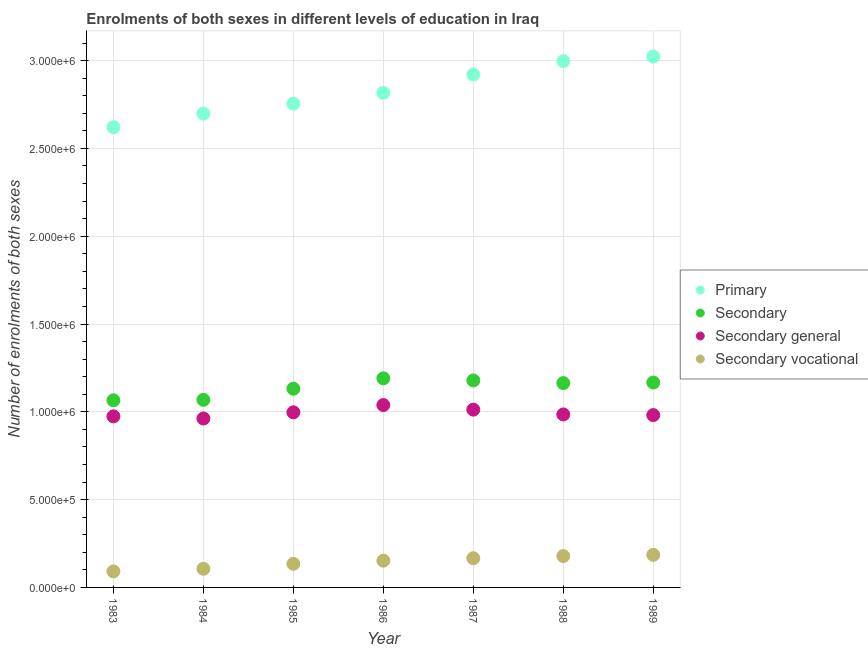What is the number of enrolments in primary education in 1983?
Your answer should be very brief. 2.62e+06. Across all years, what is the maximum number of enrolments in primary education?
Offer a terse response. 3.02e+06. Across all years, what is the minimum number of enrolments in secondary education?
Your answer should be compact. 1.07e+06. In which year was the number of enrolments in primary education maximum?
Give a very brief answer. 1989. What is the total number of enrolments in secondary vocational education in the graph?
Your answer should be compact. 1.01e+06. What is the difference between the number of enrolments in secondary education in 1983 and that in 1989?
Give a very brief answer. -1.01e+05. What is the difference between the number of enrolments in secondary education in 1989 and the number of enrolments in primary education in 1985?
Your answer should be very brief. -1.59e+06. What is the average number of enrolments in secondary general education per year?
Offer a terse response. 9.93e+05. In the year 1984, what is the difference between the number of enrolments in primary education and number of enrolments in secondary vocational education?
Provide a short and direct response. 2.59e+06. In how many years, is the number of enrolments in secondary general education greater than 1100000?
Your response must be concise. 0. What is the ratio of the number of enrolments in secondary general education in 1984 to that in 1989?
Keep it short and to the point. 0.98. Is the number of enrolments in primary education in 1983 less than that in 1989?
Offer a terse response. Yes. Is the difference between the number of enrolments in secondary general education in 1984 and 1988 greater than the difference between the number of enrolments in secondary education in 1984 and 1988?
Provide a succinct answer. Yes. What is the difference between the highest and the second highest number of enrolments in secondary general education?
Offer a very short reply. 2.62e+04. What is the difference between the highest and the lowest number of enrolments in primary education?
Provide a succinct answer. 4.02e+05. In how many years, is the number of enrolments in primary education greater than the average number of enrolments in primary education taken over all years?
Make the answer very short. 3. Is the sum of the number of enrolments in secondary general education in 1983 and 1986 greater than the maximum number of enrolments in secondary vocational education across all years?
Your answer should be compact. Yes. Is it the case that in every year, the sum of the number of enrolments in secondary education and number of enrolments in secondary vocational education is greater than the sum of number of enrolments in primary education and number of enrolments in secondary general education?
Keep it short and to the point. No. Does the number of enrolments in secondary vocational education monotonically increase over the years?
Keep it short and to the point. Yes. Is the number of enrolments in secondary vocational education strictly greater than the number of enrolments in primary education over the years?
Make the answer very short. No. How many dotlines are there?
Offer a very short reply. 4. What is the difference between two consecutive major ticks on the Y-axis?
Keep it short and to the point. 5.00e+05. Does the graph contain grids?
Your response must be concise. Yes. Where does the legend appear in the graph?
Your answer should be compact. Center right. How many legend labels are there?
Your response must be concise. 4. How are the legend labels stacked?
Provide a succinct answer. Vertical. What is the title of the graph?
Provide a succinct answer. Enrolments of both sexes in different levels of education in Iraq. What is the label or title of the X-axis?
Offer a very short reply. Year. What is the label or title of the Y-axis?
Your answer should be compact. Number of enrolments of both sexes. What is the Number of enrolments of both sexes in Primary in 1983?
Provide a succinct answer. 2.62e+06. What is the Number of enrolments of both sexes in Secondary in 1983?
Ensure brevity in your answer.  1.07e+06. What is the Number of enrolments of both sexes in Secondary general in 1983?
Your answer should be very brief. 9.74e+05. What is the Number of enrolments of both sexes in Secondary vocational in 1983?
Your answer should be very brief. 9.13e+04. What is the Number of enrolments of both sexes of Primary in 1984?
Ensure brevity in your answer.  2.70e+06. What is the Number of enrolments of both sexes in Secondary in 1984?
Give a very brief answer. 1.07e+06. What is the Number of enrolments of both sexes of Secondary general in 1984?
Make the answer very short. 9.62e+05. What is the Number of enrolments of both sexes in Secondary vocational in 1984?
Keep it short and to the point. 1.06e+05. What is the Number of enrolments of both sexes of Primary in 1985?
Keep it short and to the point. 2.75e+06. What is the Number of enrolments of both sexes in Secondary in 1985?
Make the answer very short. 1.13e+06. What is the Number of enrolments of both sexes of Secondary general in 1985?
Ensure brevity in your answer.  9.97e+05. What is the Number of enrolments of both sexes in Secondary vocational in 1985?
Your response must be concise. 1.34e+05. What is the Number of enrolments of both sexes in Primary in 1986?
Your answer should be very brief. 2.82e+06. What is the Number of enrolments of both sexes of Secondary in 1986?
Ensure brevity in your answer.  1.19e+06. What is the Number of enrolments of both sexes of Secondary general in 1986?
Provide a short and direct response. 1.04e+06. What is the Number of enrolments of both sexes in Secondary vocational in 1986?
Your response must be concise. 1.52e+05. What is the Number of enrolments of both sexes of Primary in 1987?
Keep it short and to the point. 2.92e+06. What is the Number of enrolments of both sexes in Secondary in 1987?
Ensure brevity in your answer.  1.18e+06. What is the Number of enrolments of both sexes in Secondary general in 1987?
Make the answer very short. 1.01e+06. What is the Number of enrolments of both sexes of Secondary vocational in 1987?
Your answer should be very brief. 1.66e+05. What is the Number of enrolments of both sexes of Primary in 1988?
Give a very brief answer. 3.00e+06. What is the Number of enrolments of both sexes in Secondary in 1988?
Your answer should be compact. 1.16e+06. What is the Number of enrolments of both sexes in Secondary general in 1988?
Offer a terse response. 9.85e+05. What is the Number of enrolments of both sexes of Secondary vocational in 1988?
Provide a succinct answer. 1.79e+05. What is the Number of enrolments of both sexes of Primary in 1989?
Offer a terse response. 3.02e+06. What is the Number of enrolments of both sexes of Secondary in 1989?
Provide a short and direct response. 1.17e+06. What is the Number of enrolments of both sexes of Secondary general in 1989?
Provide a short and direct response. 9.81e+05. What is the Number of enrolments of both sexes of Secondary vocational in 1989?
Your answer should be compact. 1.85e+05. Across all years, what is the maximum Number of enrolments of both sexes in Primary?
Offer a very short reply. 3.02e+06. Across all years, what is the maximum Number of enrolments of both sexes in Secondary?
Provide a short and direct response. 1.19e+06. Across all years, what is the maximum Number of enrolments of both sexes in Secondary general?
Provide a short and direct response. 1.04e+06. Across all years, what is the maximum Number of enrolments of both sexes in Secondary vocational?
Your answer should be compact. 1.85e+05. Across all years, what is the minimum Number of enrolments of both sexes of Primary?
Provide a succinct answer. 2.62e+06. Across all years, what is the minimum Number of enrolments of both sexes in Secondary?
Make the answer very short. 1.07e+06. Across all years, what is the minimum Number of enrolments of both sexes in Secondary general?
Ensure brevity in your answer.  9.62e+05. Across all years, what is the minimum Number of enrolments of both sexes of Secondary vocational?
Offer a very short reply. 9.13e+04. What is the total Number of enrolments of both sexes in Primary in the graph?
Offer a terse response. 1.98e+07. What is the total Number of enrolments of both sexes in Secondary in the graph?
Keep it short and to the point. 7.97e+06. What is the total Number of enrolments of both sexes in Secondary general in the graph?
Offer a terse response. 6.95e+06. What is the total Number of enrolments of both sexes in Secondary vocational in the graph?
Your answer should be compact. 1.01e+06. What is the difference between the Number of enrolments of both sexes in Primary in 1983 and that in 1984?
Ensure brevity in your answer.  -7.77e+04. What is the difference between the Number of enrolments of both sexes in Secondary in 1983 and that in 1984?
Offer a very short reply. -2636. What is the difference between the Number of enrolments of both sexes in Secondary general in 1983 and that in 1984?
Provide a short and direct response. 1.22e+04. What is the difference between the Number of enrolments of both sexes of Secondary vocational in 1983 and that in 1984?
Your response must be concise. -1.49e+04. What is the difference between the Number of enrolments of both sexes in Primary in 1983 and that in 1985?
Ensure brevity in your answer.  -1.34e+05. What is the difference between the Number of enrolments of both sexes of Secondary in 1983 and that in 1985?
Provide a succinct answer. -6.59e+04. What is the difference between the Number of enrolments of both sexes in Secondary general in 1983 and that in 1985?
Give a very brief answer. -2.28e+04. What is the difference between the Number of enrolments of both sexes of Secondary vocational in 1983 and that in 1985?
Provide a short and direct response. -4.31e+04. What is the difference between the Number of enrolments of both sexes of Primary in 1983 and that in 1986?
Your answer should be very brief. -1.95e+05. What is the difference between the Number of enrolments of both sexes of Secondary in 1983 and that in 1986?
Keep it short and to the point. -1.25e+05. What is the difference between the Number of enrolments of both sexes of Secondary general in 1983 and that in 1986?
Provide a short and direct response. -6.44e+04. What is the difference between the Number of enrolments of both sexes in Secondary vocational in 1983 and that in 1986?
Ensure brevity in your answer.  -6.09e+04. What is the difference between the Number of enrolments of both sexes of Primary in 1983 and that in 1987?
Ensure brevity in your answer.  -3.00e+05. What is the difference between the Number of enrolments of both sexes in Secondary in 1983 and that in 1987?
Your answer should be compact. -1.13e+05. What is the difference between the Number of enrolments of both sexes in Secondary general in 1983 and that in 1987?
Your answer should be compact. -3.82e+04. What is the difference between the Number of enrolments of both sexes of Secondary vocational in 1983 and that in 1987?
Your answer should be compact. -7.50e+04. What is the difference between the Number of enrolments of both sexes of Primary in 1983 and that in 1988?
Your response must be concise. -3.76e+05. What is the difference between the Number of enrolments of both sexes in Secondary in 1983 and that in 1988?
Your answer should be compact. -9.81e+04. What is the difference between the Number of enrolments of both sexes in Secondary general in 1983 and that in 1988?
Make the answer very short. -1.09e+04. What is the difference between the Number of enrolments of both sexes in Secondary vocational in 1983 and that in 1988?
Your answer should be compact. -8.72e+04. What is the difference between the Number of enrolments of both sexes in Primary in 1983 and that in 1989?
Your answer should be very brief. -4.02e+05. What is the difference between the Number of enrolments of both sexes in Secondary in 1983 and that in 1989?
Your response must be concise. -1.01e+05. What is the difference between the Number of enrolments of both sexes of Secondary general in 1983 and that in 1989?
Offer a very short reply. -7159. What is the difference between the Number of enrolments of both sexes in Secondary vocational in 1983 and that in 1989?
Provide a short and direct response. -9.41e+04. What is the difference between the Number of enrolments of both sexes in Primary in 1984 and that in 1985?
Offer a terse response. -5.63e+04. What is the difference between the Number of enrolments of both sexes in Secondary in 1984 and that in 1985?
Keep it short and to the point. -6.33e+04. What is the difference between the Number of enrolments of both sexes of Secondary general in 1984 and that in 1985?
Make the answer very short. -3.51e+04. What is the difference between the Number of enrolments of both sexes of Secondary vocational in 1984 and that in 1985?
Your answer should be compact. -2.82e+04. What is the difference between the Number of enrolments of both sexes of Primary in 1984 and that in 1986?
Keep it short and to the point. -1.18e+05. What is the difference between the Number of enrolments of both sexes of Secondary in 1984 and that in 1986?
Your answer should be very brief. -1.23e+05. What is the difference between the Number of enrolments of both sexes of Secondary general in 1984 and that in 1986?
Provide a succinct answer. -7.66e+04. What is the difference between the Number of enrolments of both sexes in Secondary vocational in 1984 and that in 1986?
Your answer should be very brief. -4.60e+04. What is the difference between the Number of enrolments of both sexes of Primary in 1984 and that in 1987?
Keep it short and to the point. -2.22e+05. What is the difference between the Number of enrolments of both sexes in Secondary in 1984 and that in 1987?
Give a very brief answer. -1.11e+05. What is the difference between the Number of enrolments of both sexes in Secondary general in 1984 and that in 1987?
Your answer should be very brief. -5.04e+04. What is the difference between the Number of enrolments of both sexes of Secondary vocational in 1984 and that in 1987?
Make the answer very short. -6.01e+04. What is the difference between the Number of enrolments of both sexes in Primary in 1984 and that in 1988?
Keep it short and to the point. -2.98e+05. What is the difference between the Number of enrolments of both sexes in Secondary in 1984 and that in 1988?
Offer a very short reply. -9.55e+04. What is the difference between the Number of enrolments of both sexes in Secondary general in 1984 and that in 1988?
Your answer should be compact. -2.31e+04. What is the difference between the Number of enrolments of both sexes of Secondary vocational in 1984 and that in 1988?
Give a very brief answer. -7.24e+04. What is the difference between the Number of enrolments of both sexes of Primary in 1984 and that in 1989?
Keep it short and to the point. -3.25e+05. What is the difference between the Number of enrolments of both sexes in Secondary in 1984 and that in 1989?
Offer a terse response. -9.86e+04. What is the difference between the Number of enrolments of both sexes in Secondary general in 1984 and that in 1989?
Provide a short and direct response. -1.94e+04. What is the difference between the Number of enrolments of both sexes of Secondary vocational in 1984 and that in 1989?
Provide a succinct answer. -7.92e+04. What is the difference between the Number of enrolments of both sexes of Primary in 1985 and that in 1986?
Your answer should be very brief. -6.14e+04. What is the difference between the Number of enrolments of both sexes in Secondary in 1985 and that in 1986?
Your answer should be very brief. -5.93e+04. What is the difference between the Number of enrolments of both sexes in Secondary general in 1985 and that in 1986?
Keep it short and to the point. -4.16e+04. What is the difference between the Number of enrolments of both sexes of Secondary vocational in 1985 and that in 1986?
Give a very brief answer. -1.78e+04. What is the difference between the Number of enrolments of both sexes of Primary in 1985 and that in 1987?
Offer a very short reply. -1.66e+05. What is the difference between the Number of enrolments of both sexes of Secondary in 1985 and that in 1987?
Your response must be concise. -4.72e+04. What is the difference between the Number of enrolments of both sexes in Secondary general in 1985 and that in 1987?
Offer a very short reply. -1.54e+04. What is the difference between the Number of enrolments of both sexes of Secondary vocational in 1985 and that in 1987?
Provide a succinct answer. -3.19e+04. What is the difference between the Number of enrolments of both sexes of Primary in 1985 and that in 1988?
Your response must be concise. -2.42e+05. What is the difference between the Number of enrolments of both sexes of Secondary in 1985 and that in 1988?
Make the answer very short. -3.22e+04. What is the difference between the Number of enrolments of both sexes in Secondary general in 1985 and that in 1988?
Provide a succinct answer. 1.19e+04. What is the difference between the Number of enrolments of both sexes of Secondary vocational in 1985 and that in 1988?
Ensure brevity in your answer.  -4.41e+04. What is the difference between the Number of enrolments of both sexes in Primary in 1985 and that in 1989?
Provide a succinct answer. -2.68e+05. What is the difference between the Number of enrolments of both sexes in Secondary in 1985 and that in 1989?
Your response must be concise. -3.53e+04. What is the difference between the Number of enrolments of both sexes in Secondary general in 1985 and that in 1989?
Your answer should be very brief. 1.57e+04. What is the difference between the Number of enrolments of both sexes of Secondary vocational in 1985 and that in 1989?
Your answer should be very brief. -5.10e+04. What is the difference between the Number of enrolments of both sexes in Primary in 1986 and that in 1987?
Give a very brief answer. -1.05e+05. What is the difference between the Number of enrolments of both sexes of Secondary in 1986 and that in 1987?
Keep it short and to the point. 1.21e+04. What is the difference between the Number of enrolments of both sexes of Secondary general in 1986 and that in 1987?
Offer a terse response. 2.62e+04. What is the difference between the Number of enrolments of both sexes of Secondary vocational in 1986 and that in 1987?
Give a very brief answer. -1.41e+04. What is the difference between the Number of enrolments of both sexes in Primary in 1986 and that in 1988?
Keep it short and to the point. -1.81e+05. What is the difference between the Number of enrolments of both sexes in Secondary in 1986 and that in 1988?
Your answer should be compact. 2.71e+04. What is the difference between the Number of enrolments of both sexes in Secondary general in 1986 and that in 1988?
Your answer should be compact. 5.35e+04. What is the difference between the Number of enrolments of both sexes of Secondary vocational in 1986 and that in 1988?
Give a very brief answer. -2.64e+04. What is the difference between the Number of enrolments of both sexes in Primary in 1986 and that in 1989?
Ensure brevity in your answer.  -2.07e+05. What is the difference between the Number of enrolments of both sexes in Secondary in 1986 and that in 1989?
Ensure brevity in your answer.  2.40e+04. What is the difference between the Number of enrolments of both sexes of Secondary general in 1986 and that in 1989?
Offer a very short reply. 5.72e+04. What is the difference between the Number of enrolments of both sexes of Secondary vocational in 1986 and that in 1989?
Your answer should be compact. -3.32e+04. What is the difference between the Number of enrolments of both sexes in Primary in 1987 and that in 1988?
Provide a short and direct response. -7.60e+04. What is the difference between the Number of enrolments of both sexes in Secondary in 1987 and that in 1988?
Offer a very short reply. 1.51e+04. What is the difference between the Number of enrolments of both sexes in Secondary general in 1987 and that in 1988?
Make the answer very short. 2.73e+04. What is the difference between the Number of enrolments of both sexes of Secondary vocational in 1987 and that in 1988?
Offer a terse response. -1.22e+04. What is the difference between the Number of enrolments of both sexes in Primary in 1987 and that in 1989?
Your answer should be very brief. -1.02e+05. What is the difference between the Number of enrolments of both sexes in Secondary in 1987 and that in 1989?
Ensure brevity in your answer.  1.19e+04. What is the difference between the Number of enrolments of both sexes in Secondary general in 1987 and that in 1989?
Provide a succinct answer. 3.10e+04. What is the difference between the Number of enrolments of both sexes of Secondary vocational in 1987 and that in 1989?
Your response must be concise. -1.91e+04. What is the difference between the Number of enrolments of both sexes of Primary in 1988 and that in 1989?
Keep it short and to the point. -2.62e+04. What is the difference between the Number of enrolments of both sexes of Secondary in 1988 and that in 1989?
Keep it short and to the point. -3165. What is the difference between the Number of enrolments of both sexes in Secondary general in 1988 and that in 1989?
Your response must be concise. 3714. What is the difference between the Number of enrolments of both sexes in Secondary vocational in 1988 and that in 1989?
Your answer should be very brief. -6879. What is the difference between the Number of enrolments of both sexes in Primary in 1983 and the Number of enrolments of both sexes in Secondary in 1984?
Make the answer very short. 1.55e+06. What is the difference between the Number of enrolments of both sexes of Primary in 1983 and the Number of enrolments of both sexes of Secondary general in 1984?
Keep it short and to the point. 1.66e+06. What is the difference between the Number of enrolments of both sexes in Primary in 1983 and the Number of enrolments of both sexes in Secondary vocational in 1984?
Provide a short and direct response. 2.51e+06. What is the difference between the Number of enrolments of both sexes in Secondary in 1983 and the Number of enrolments of both sexes in Secondary general in 1984?
Ensure brevity in your answer.  1.04e+05. What is the difference between the Number of enrolments of both sexes of Secondary in 1983 and the Number of enrolments of both sexes of Secondary vocational in 1984?
Your answer should be compact. 9.59e+05. What is the difference between the Number of enrolments of both sexes of Secondary general in 1983 and the Number of enrolments of both sexes of Secondary vocational in 1984?
Make the answer very short. 8.68e+05. What is the difference between the Number of enrolments of both sexes in Primary in 1983 and the Number of enrolments of both sexes in Secondary in 1985?
Provide a short and direct response. 1.49e+06. What is the difference between the Number of enrolments of both sexes in Primary in 1983 and the Number of enrolments of both sexes in Secondary general in 1985?
Your answer should be very brief. 1.62e+06. What is the difference between the Number of enrolments of both sexes of Primary in 1983 and the Number of enrolments of both sexes of Secondary vocational in 1985?
Your response must be concise. 2.49e+06. What is the difference between the Number of enrolments of both sexes in Secondary in 1983 and the Number of enrolments of both sexes in Secondary general in 1985?
Your answer should be compact. 6.85e+04. What is the difference between the Number of enrolments of both sexes of Secondary in 1983 and the Number of enrolments of both sexes of Secondary vocational in 1985?
Provide a succinct answer. 9.31e+05. What is the difference between the Number of enrolments of both sexes of Secondary general in 1983 and the Number of enrolments of both sexes of Secondary vocational in 1985?
Provide a short and direct response. 8.40e+05. What is the difference between the Number of enrolments of both sexes of Primary in 1983 and the Number of enrolments of both sexes of Secondary in 1986?
Your answer should be compact. 1.43e+06. What is the difference between the Number of enrolments of both sexes of Primary in 1983 and the Number of enrolments of both sexes of Secondary general in 1986?
Make the answer very short. 1.58e+06. What is the difference between the Number of enrolments of both sexes in Primary in 1983 and the Number of enrolments of both sexes in Secondary vocational in 1986?
Your answer should be very brief. 2.47e+06. What is the difference between the Number of enrolments of both sexes in Secondary in 1983 and the Number of enrolments of both sexes in Secondary general in 1986?
Give a very brief answer. 2.70e+04. What is the difference between the Number of enrolments of both sexes in Secondary in 1983 and the Number of enrolments of both sexes in Secondary vocational in 1986?
Offer a very short reply. 9.13e+05. What is the difference between the Number of enrolments of both sexes of Secondary general in 1983 and the Number of enrolments of both sexes of Secondary vocational in 1986?
Your answer should be very brief. 8.22e+05. What is the difference between the Number of enrolments of both sexes of Primary in 1983 and the Number of enrolments of both sexes of Secondary in 1987?
Give a very brief answer. 1.44e+06. What is the difference between the Number of enrolments of both sexes in Primary in 1983 and the Number of enrolments of both sexes in Secondary general in 1987?
Give a very brief answer. 1.61e+06. What is the difference between the Number of enrolments of both sexes in Primary in 1983 and the Number of enrolments of both sexes in Secondary vocational in 1987?
Provide a short and direct response. 2.45e+06. What is the difference between the Number of enrolments of both sexes of Secondary in 1983 and the Number of enrolments of both sexes of Secondary general in 1987?
Your answer should be compact. 5.32e+04. What is the difference between the Number of enrolments of both sexes of Secondary in 1983 and the Number of enrolments of both sexes of Secondary vocational in 1987?
Make the answer very short. 8.99e+05. What is the difference between the Number of enrolments of both sexes of Secondary general in 1983 and the Number of enrolments of both sexes of Secondary vocational in 1987?
Give a very brief answer. 8.08e+05. What is the difference between the Number of enrolments of both sexes of Primary in 1983 and the Number of enrolments of both sexes of Secondary in 1988?
Your response must be concise. 1.46e+06. What is the difference between the Number of enrolments of both sexes of Primary in 1983 and the Number of enrolments of both sexes of Secondary general in 1988?
Your answer should be compact. 1.64e+06. What is the difference between the Number of enrolments of both sexes in Primary in 1983 and the Number of enrolments of both sexes in Secondary vocational in 1988?
Provide a short and direct response. 2.44e+06. What is the difference between the Number of enrolments of both sexes of Secondary in 1983 and the Number of enrolments of both sexes of Secondary general in 1988?
Your answer should be very brief. 8.05e+04. What is the difference between the Number of enrolments of both sexes of Secondary in 1983 and the Number of enrolments of both sexes of Secondary vocational in 1988?
Keep it short and to the point. 8.87e+05. What is the difference between the Number of enrolments of both sexes in Secondary general in 1983 and the Number of enrolments of both sexes in Secondary vocational in 1988?
Make the answer very short. 7.96e+05. What is the difference between the Number of enrolments of both sexes in Primary in 1983 and the Number of enrolments of both sexes in Secondary in 1989?
Give a very brief answer. 1.45e+06. What is the difference between the Number of enrolments of both sexes in Primary in 1983 and the Number of enrolments of both sexes in Secondary general in 1989?
Your answer should be compact. 1.64e+06. What is the difference between the Number of enrolments of both sexes of Primary in 1983 and the Number of enrolments of both sexes of Secondary vocational in 1989?
Keep it short and to the point. 2.44e+06. What is the difference between the Number of enrolments of both sexes of Secondary in 1983 and the Number of enrolments of both sexes of Secondary general in 1989?
Make the answer very short. 8.42e+04. What is the difference between the Number of enrolments of both sexes in Secondary in 1983 and the Number of enrolments of both sexes in Secondary vocational in 1989?
Offer a terse response. 8.80e+05. What is the difference between the Number of enrolments of both sexes in Secondary general in 1983 and the Number of enrolments of both sexes in Secondary vocational in 1989?
Make the answer very short. 7.89e+05. What is the difference between the Number of enrolments of both sexes of Primary in 1984 and the Number of enrolments of both sexes of Secondary in 1985?
Give a very brief answer. 1.57e+06. What is the difference between the Number of enrolments of both sexes of Primary in 1984 and the Number of enrolments of both sexes of Secondary general in 1985?
Ensure brevity in your answer.  1.70e+06. What is the difference between the Number of enrolments of both sexes in Primary in 1984 and the Number of enrolments of both sexes in Secondary vocational in 1985?
Give a very brief answer. 2.56e+06. What is the difference between the Number of enrolments of both sexes of Secondary in 1984 and the Number of enrolments of both sexes of Secondary general in 1985?
Your answer should be very brief. 7.12e+04. What is the difference between the Number of enrolments of both sexes in Secondary in 1984 and the Number of enrolments of both sexes in Secondary vocational in 1985?
Offer a terse response. 9.34e+05. What is the difference between the Number of enrolments of both sexes in Secondary general in 1984 and the Number of enrolments of both sexes in Secondary vocational in 1985?
Your answer should be compact. 8.28e+05. What is the difference between the Number of enrolments of both sexes of Primary in 1984 and the Number of enrolments of both sexes of Secondary in 1986?
Your response must be concise. 1.51e+06. What is the difference between the Number of enrolments of both sexes in Primary in 1984 and the Number of enrolments of both sexes in Secondary general in 1986?
Provide a short and direct response. 1.66e+06. What is the difference between the Number of enrolments of both sexes of Primary in 1984 and the Number of enrolments of both sexes of Secondary vocational in 1986?
Provide a succinct answer. 2.55e+06. What is the difference between the Number of enrolments of both sexes in Secondary in 1984 and the Number of enrolments of both sexes in Secondary general in 1986?
Give a very brief answer. 2.96e+04. What is the difference between the Number of enrolments of both sexes in Secondary in 1984 and the Number of enrolments of both sexes in Secondary vocational in 1986?
Your answer should be very brief. 9.16e+05. What is the difference between the Number of enrolments of both sexes of Secondary general in 1984 and the Number of enrolments of both sexes of Secondary vocational in 1986?
Ensure brevity in your answer.  8.10e+05. What is the difference between the Number of enrolments of both sexes in Primary in 1984 and the Number of enrolments of both sexes in Secondary in 1987?
Your answer should be compact. 1.52e+06. What is the difference between the Number of enrolments of both sexes in Primary in 1984 and the Number of enrolments of both sexes in Secondary general in 1987?
Ensure brevity in your answer.  1.69e+06. What is the difference between the Number of enrolments of both sexes of Primary in 1984 and the Number of enrolments of both sexes of Secondary vocational in 1987?
Offer a terse response. 2.53e+06. What is the difference between the Number of enrolments of both sexes in Secondary in 1984 and the Number of enrolments of both sexes in Secondary general in 1987?
Offer a terse response. 5.58e+04. What is the difference between the Number of enrolments of both sexes in Secondary in 1984 and the Number of enrolments of both sexes in Secondary vocational in 1987?
Your answer should be compact. 9.02e+05. What is the difference between the Number of enrolments of both sexes in Secondary general in 1984 and the Number of enrolments of both sexes in Secondary vocational in 1987?
Provide a succinct answer. 7.96e+05. What is the difference between the Number of enrolments of both sexes of Primary in 1984 and the Number of enrolments of both sexes of Secondary in 1988?
Provide a succinct answer. 1.53e+06. What is the difference between the Number of enrolments of both sexes of Primary in 1984 and the Number of enrolments of both sexes of Secondary general in 1988?
Keep it short and to the point. 1.71e+06. What is the difference between the Number of enrolments of both sexes in Primary in 1984 and the Number of enrolments of both sexes in Secondary vocational in 1988?
Make the answer very short. 2.52e+06. What is the difference between the Number of enrolments of both sexes in Secondary in 1984 and the Number of enrolments of both sexes in Secondary general in 1988?
Your answer should be very brief. 8.31e+04. What is the difference between the Number of enrolments of both sexes in Secondary in 1984 and the Number of enrolments of both sexes in Secondary vocational in 1988?
Give a very brief answer. 8.90e+05. What is the difference between the Number of enrolments of both sexes of Secondary general in 1984 and the Number of enrolments of both sexes of Secondary vocational in 1988?
Your answer should be compact. 7.83e+05. What is the difference between the Number of enrolments of both sexes in Primary in 1984 and the Number of enrolments of both sexes in Secondary in 1989?
Provide a succinct answer. 1.53e+06. What is the difference between the Number of enrolments of both sexes in Primary in 1984 and the Number of enrolments of both sexes in Secondary general in 1989?
Your answer should be very brief. 1.72e+06. What is the difference between the Number of enrolments of both sexes in Primary in 1984 and the Number of enrolments of both sexes in Secondary vocational in 1989?
Provide a short and direct response. 2.51e+06. What is the difference between the Number of enrolments of both sexes of Secondary in 1984 and the Number of enrolments of both sexes of Secondary general in 1989?
Your response must be concise. 8.68e+04. What is the difference between the Number of enrolments of both sexes in Secondary in 1984 and the Number of enrolments of both sexes in Secondary vocational in 1989?
Your answer should be very brief. 8.83e+05. What is the difference between the Number of enrolments of both sexes in Secondary general in 1984 and the Number of enrolments of both sexes in Secondary vocational in 1989?
Keep it short and to the point. 7.77e+05. What is the difference between the Number of enrolments of both sexes of Primary in 1985 and the Number of enrolments of both sexes of Secondary in 1986?
Ensure brevity in your answer.  1.56e+06. What is the difference between the Number of enrolments of both sexes of Primary in 1985 and the Number of enrolments of both sexes of Secondary general in 1986?
Ensure brevity in your answer.  1.72e+06. What is the difference between the Number of enrolments of both sexes of Primary in 1985 and the Number of enrolments of both sexes of Secondary vocational in 1986?
Offer a very short reply. 2.60e+06. What is the difference between the Number of enrolments of both sexes of Secondary in 1985 and the Number of enrolments of both sexes of Secondary general in 1986?
Offer a terse response. 9.29e+04. What is the difference between the Number of enrolments of both sexes in Secondary in 1985 and the Number of enrolments of both sexes in Secondary vocational in 1986?
Make the answer very short. 9.79e+05. What is the difference between the Number of enrolments of both sexes in Secondary general in 1985 and the Number of enrolments of both sexes in Secondary vocational in 1986?
Provide a short and direct response. 8.45e+05. What is the difference between the Number of enrolments of both sexes of Primary in 1985 and the Number of enrolments of both sexes of Secondary in 1987?
Provide a succinct answer. 1.58e+06. What is the difference between the Number of enrolments of both sexes in Primary in 1985 and the Number of enrolments of both sexes in Secondary general in 1987?
Provide a short and direct response. 1.74e+06. What is the difference between the Number of enrolments of both sexes of Primary in 1985 and the Number of enrolments of both sexes of Secondary vocational in 1987?
Provide a short and direct response. 2.59e+06. What is the difference between the Number of enrolments of both sexes in Secondary in 1985 and the Number of enrolments of both sexes in Secondary general in 1987?
Provide a short and direct response. 1.19e+05. What is the difference between the Number of enrolments of both sexes of Secondary in 1985 and the Number of enrolments of both sexes of Secondary vocational in 1987?
Your answer should be compact. 9.65e+05. What is the difference between the Number of enrolments of both sexes of Secondary general in 1985 and the Number of enrolments of both sexes of Secondary vocational in 1987?
Offer a very short reply. 8.31e+05. What is the difference between the Number of enrolments of both sexes of Primary in 1985 and the Number of enrolments of both sexes of Secondary in 1988?
Your answer should be very brief. 1.59e+06. What is the difference between the Number of enrolments of both sexes of Primary in 1985 and the Number of enrolments of both sexes of Secondary general in 1988?
Give a very brief answer. 1.77e+06. What is the difference between the Number of enrolments of both sexes in Primary in 1985 and the Number of enrolments of both sexes in Secondary vocational in 1988?
Provide a short and direct response. 2.58e+06. What is the difference between the Number of enrolments of both sexes in Secondary in 1985 and the Number of enrolments of both sexes in Secondary general in 1988?
Ensure brevity in your answer.  1.46e+05. What is the difference between the Number of enrolments of both sexes of Secondary in 1985 and the Number of enrolments of both sexes of Secondary vocational in 1988?
Ensure brevity in your answer.  9.53e+05. What is the difference between the Number of enrolments of both sexes in Secondary general in 1985 and the Number of enrolments of both sexes in Secondary vocational in 1988?
Provide a short and direct response. 8.18e+05. What is the difference between the Number of enrolments of both sexes in Primary in 1985 and the Number of enrolments of both sexes in Secondary in 1989?
Give a very brief answer. 1.59e+06. What is the difference between the Number of enrolments of both sexes of Primary in 1985 and the Number of enrolments of both sexes of Secondary general in 1989?
Keep it short and to the point. 1.77e+06. What is the difference between the Number of enrolments of both sexes in Primary in 1985 and the Number of enrolments of both sexes in Secondary vocational in 1989?
Your answer should be very brief. 2.57e+06. What is the difference between the Number of enrolments of both sexes in Secondary in 1985 and the Number of enrolments of both sexes in Secondary general in 1989?
Your answer should be compact. 1.50e+05. What is the difference between the Number of enrolments of both sexes of Secondary in 1985 and the Number of enrolments of both sexes of Secondary vocational in 1989?
Offer a very short reply. 9.46e+05. What is the difference between the Number of enrolments of both sexes in Secondary general in 1985 and the Number of enrolments of both sexes in Secondary vocational in 1989?
Keep it short and to the point. 8.12e+05. What is the difference between the Number of enrolments of both sexes of Primary in 1986 and the Number of enrolments of both sexes of Secondary in 1987?
Make the answer very short. 1.64e+06. What is the difference between the Number of enrolments of both sexes of Primary in 1986 and the Number of enrolments of both sexes of Secondary general in 1987?
Keep it short and to the point. 1.80e+06. What is the difference between the Number of enrolments of both sexes in Primary in 1986 and the Number of enrolments of both sexes in Secondary vocational in 1987?
Offer a very short reply. 2.65e+06. What is the difference between the Number of enrolments of both sexes in Secondary in 1986 and the Number of enrolments of both sexes in Secondary general in 1987?
Ensure brevity in your answer.  1.78e+05. What is the difference between the Number of enrolments of both sexes of Secondary in 1986 and the Number of enrolments of both sexes of Secondary vocational in 1987?
Make the answer very short. 1.02e+06. What is the difference between the Number of enrolments of both sexes in Secondary general in 1986 and the Number of enrolments of both sexes in Secondary vocational in 1987?
Offer a terse response. 8.72e+05. What is the difference between the Number of enrolments of both sexes in Primary in 1986 and the Number of enrolments of both sexes in Secondary in 1988?
Provide a short and direct response. 1.65e+06. What is the difference between the Number of enrolments of both sexes in Primary in 1986 and the Number of enrolments of both sexes in Secondary general in 1988?
Your response must be concise. 1.83e+06. What is the difference between the Number of enrolments of both sexes in Primary in 1986 and the Number of enrolments of both sexes in Secondary vocational in 1988?
Provide a short and direct response. 2.64e+06. What is the difference between the Number of enrolments of both sexes of Secondary in 1986 and the Number of enrolments of both sexes of Secondary general in 1988?
Your answer should be very brief. 2.06e+05. What is the difference between the Number of enrolments of both sexes of Secondary in 1986 and the Number of enrolments of both sexes of Secondary vocational in 1988?
Your answer should be very brief. 1.01e+06. What is the difference between the Number of enrolments of both sexes in Secondary general in 1986 and the Number of enrolments of both sexes in Secondary vocational in 1988?
Make the answer very short. 8.60e+05. What is the difference between the Number of enrolments of both sexes in Primary in 1986 and the Number of enrolments of both sexes in Secondary in 1989?
Provide a short and direct response. 1.65e+06. What is the difference between the Number of enrolments of both sexes of Primary in 1986 and the Number of enrolments of both sexes of Secondary general in 1989?
Make the answer very short. 1.83e+06. What is the difference between the Number of enrolments of both sexes in Primary in 1986 and the Number of enrolments of both sexes in Secondary vocational in 1989?
Offer a terse response. 2.63e+06. What is the difference between the Number of enrolments of both sexes of Secondary in 1986 and the Number of enrolments of both sexes of Secondary general in 1989?
Make the answer very short. 2.09e+05. What is the difference between the Number of enrolments of both sexes of Secondary in 1986 and the Number of enrolments of both sexes of Secondary vocational in 1989?
Offer a very short reply. 1.01e+06. What is the difference between the Number of enrolments of both sexes in Secondary general in 1986 and the Number of enrolments of both sexes in Secondary vocational in 1989?
Provide a succinct answer. 8.53e+05. What is the difference between the Number of enrolments of both sexes of Primary in 1987 and the Number of enrolments of both sexes of Secondary in 1988?
Your answer should be very brief. 1.76e+06. What is the difference between the Number of enrolments of both sexes in Primary in 1987 and the Number of enrolments of both sexes in Secondary general in 1988?
Keep it short and to the point. 1.94e+06. What is the difference between the Number of enrolments of both sexes of Primary in 1987 and the Number of enrolments of both sexes of Secondary vocational in 1988?
Offer a terse response. 2.74e+06. What is the difference between the Number of enrolments of both sexes in Secondary in 1987 and the Number of enrolments of both sexes in Secondary general in 1988?
Offer a very short reply. 1.94e+05. What is the difference between the Number of enrolments of both sexes of Secondary in 1987 and the Number of enrolments of both sexes of Secondary vocational in 1988?
Make the answer very short. 1.00e+06. What is the difference between the Number of enrolments of both sexes in Secondary general in 1987 and the Number of enrolments of both sexes in Secondary vocational in 1988?
Ensure brevity in your answer.  8.34e+05. What is the difference between the Number of enrolments of both sexes of Primary in 1987 and the Number of enrolments of both sexes of Secondary in 1989?
Your answer should be very brief. 1.75e+06. What is the difference between the Number of enrolments of both sexes in Primary in 1987 and the Number of enrolments of both sexes in Secondary general in 1989?
Provide a succinct answer. 1.94e+06. What is the difference between the Number of enrolments of both sexes in Primary in 1987 and the Number of enrolments of both sexes in Secondary vocational in 1989?
Keep it short and to the point. 2.74e+06. What is the difference between the Number of enrolments of both sexes in Secondary in 1987 and the Number of enrolments of both sexes in Secondary general in 1989?
Make the answer very short. 1.97e+05. What is the difference between the Number of enrolments of both sexes of Secondary in 1987 and the Number of enrolments of both sexes of Secondary vocational in 1989?
Your response must be concise. 9.93e+05. What is the difference between the Number of enrolments of both sexes in Secondary general in 1987 and the Number of enrolments of both sexes in Secondary vocational in 1989?
Give a very brief answer. 8.27e+05. What is the difference between the Number of enrolments of both sexes in Primary in 1988 and the Number of enrolments of both sexes in Secondary in 1989?
Provide a short and direct response. 1.83e+06. What is the difference between the Number of enrolments of both sexes in Primary in 1988 and the Number of enrolments of both sexes in Secondary general in 1989?
Offer a terse response. 2.02e+06. What is the difference between the Number of enrolments of both sexes in Primary in 1988 and the Number of enrolments of both sexes in Secondary vocational in 1989?
Offer a terse response. 2.81e+06. What is the difference between the Number of enrolments of both sexes of Secondary in 1988 and the Number of enrolments of both sexes of Secondary general in 1989?
Provide a short and direct response. 1.82e+05. What is the difference between the Number of enrolments of both sexes of Secondary in 1988 and the Number of enrolments of both sexes of Secondary vocational in 1989?
Make the answer very short. 9.78e+05. What is the difference between the Number of enrolments of both sexes of Secondary general in 1988 and the Number of enrolments of both sexes of Secondary vocational in 1989?
Make the answer very short. 8.00e+05. What is the average Number of enrolments of both sexes in Primary per year?
Your answer should be compact. 2.83e+06. What is the average Number of enrolments of both sexes of Secondary per year?
Offer a very short reply. 1.14e+06. What is the average Number of enrolments of both sexes of Secondary general per year?
Provide a short and direct response. 9.93e+05. What is the average Number of enrolments of both sexes in Secondary vocational per year?
Offer a terse response. 1.45e+05. In the year 1983, what is the difference between the Number of enrolments of both sexes of Primary and Number of enrolments of both sexes of Secondary?
Your answer should be very brief. 1.56e+06. In the year 1983, what is the difference between the Number of enrolments of both sexes of Primary and Number of enrolments of both sexes of Secondary general?
Your response must be concise. 1.65e+06. In the year 1983, what is the difference between the Number of enrolments of both sexes in Primary and Number of enrolments of both sexes in Secondary vocational?
Your answer should be compact. 2.53e+06. In the year 1983, what is the difference between the Number of enrolments of both sexes in Secondary and Number of enrolments of both sexes in Secondary general?
Keep it short and to the point. 9.13e+04. In the year 1983, what is the difference between the Number of enrolments of both sexes in Secondary and Number of enrolments of both sexes in Secondary vocational?
Your answer should be compact. 9.74e+05. In the year 1983, what is the difference between the Number of enrolments of both sexes in Secondary general and Number of enrolments of both sexes in Secondary vocational?
Make the answer very short. 8.83e+05. In the year 1984, what is the difference between the Number of enrolments of both sexes of Primary and Number of enrolments of both sexes of Secondary?
Keep it short and to the point. 1.63e+06. In the year 1984, what is the difference between the Number of enrolments of both sexes in Primary and Number of enrolments of both sexes in Secondary general?
Offer a terse response. 1.74e+06. In the year 1984, what is the difference between the Number of enrolments of both sexes in Primary and Number of enrolments of both sexes in Secondary vocational?
Provide a succinct answer. 2.59e+06. In the year 1984, what is the difference between the Number of enrolments of both sexes of Secondary and Number of enrolments of both sexes of Secondary general?
Make the answer very short. 1.06e+05. In the year 1984, what is the difference between the Number of enrolments of both sexes in Secondary and Number of enrolments of both sexes in Secondary vocational?
Your response must be concise. 9.62e+05. In the year 1984, what is the difference between the Number of enrolments of both sexes in Secondary general and Number of enrolments of both sexes in Secondary vocational?
Provide a succinct answer. 8.56e+05. In the year 1985, what is the difference between the Number of enrolments of both sexes of Primary and Number of enrolments of both sexes of Secondary?
Your response must be concise. 1.62e+06. In the year 1985, what is the difference between the Number of enrolments of both sexes of Primary and Number of enrolments of both sexes of Secondary general?
Your answer should be compact. 1.76e+06. In the year 1985, what is the difference between the Number of enrolments of both sexes of Primary and Number of enrolments of both sexes of Secondary vocational?
Ensure brevity in your answer.  2.62e+06. In the year 1985, what is the difference between the Number of enrolments of both sexes in Secondary and Number of enrolments of both sexes in Secondary general?
Offer a terse response. 1.34e+05. In the year 1985, what is the difference between the Number of enrolments of both sexes in Secondary and Number of enrolments of both sexes in Secondary vocational?
Your answer should be very brief. 9.97e+05. In the year 1985, what is the difference between the Number of enrolments of both sexes in Secondary general and Number of enrolments of both sexes in Secondary vocational?
Give a very brief answer. 8.63e+05. In the year 1986, what is the difference between the Number of enrolments of both sexes of Primary and Number of enrolments of both sexes of Secondary?
Make the answer very short. 1.63e+06. In the year 1986, what is the difference between the Number of enrolments of both sexes in Primary and Number of enrolments of both sexes in Secondary general?
Keep it short and to the point. 1.78e+06. In the year 1986, what is the difference between the Number of enrolments of both sexes in Primary and Number of enrolments of both sexes in Secondary vocational?
Your answer should be compact. 2.66e+06. In the year 1986, what is the difference between the Number of enrolments of both sexes of Secondary and Number of enrolments of both sexes of Secondary general?
Offer a very short reply. 1.52e+05. In the year 1986, what is the difference between the Number of enrolments of both sexes of Secondary and Number of enrolments of both sexes of Secondary vocational?
Give a very brief answer. 1.04e+06. In the year 1986, what is the difference between the Number of enrolments of both sexes in Secondary general and Number of enrolments of both sexes in Secondary vocational?
Your response must be concise. 8.86e+05. In the year 1987, what is the difference between the Number of enrolments of both sexes in Primary and Number of enrolments of both sexes in Secondary?
Ensure brevity in your answer.  1.74e+06. In the year 1987, what is the difference between the Number of enrolments of both sexes of Primary and Number of enrolments of both sexes of Secondary general?
Your answer should be compact. 1.91e+06. In the year 1987, what is the difference between the Number of enrolments of both sexes of Primary and Number of enrolments of both sexes of Secondary vocational?
Your response must be concise. 2.75e+06. In the year 1987, what is the difference between the Number of enrolments of both sexes in Secondary and Number of enrolments of both sexes in Secondary general?
Your answer should be very brief. 1.66e+05. In the year 1987, what is the difference between the Number of enrolments of both sexes of Secondary and Number of enrolments of both sexes of Secondary vocational?
Keep it short and to the point. 1.01e+06. In the year 1987, what is the difference between the Number of enrolments of both sexes in Secondary general and Number of enrolments of both sexes in Secondary vocational?
Make the answer very short. 8.46e+05. In the year 1988, what is the difference between the Number of enrolments of both sexes of Primary and Number of enrolments of both sexes of Secondary?
Your answer should be very brief. 1.83e+06. In the year 1988, what is the difference between the Number of enrolments of both sexes of Primary and Number of enrolments of both sexes of Secondary general?
Provide a short and direct response. 2.01e+06. In the year 1988, what is the difference between the Number of enrolments of both sexes in Primary and Number of enrolments of both sexes in Secondary vocational?
Offer a terse response. 2.82e+06. In the year 1988, what is the difference between the Number of enrolments of both sexes of Secondary and Number of enrolments of both sexes of Secondary general?
Ensure brevity in your answer.  1.79e+05. In the year 1988, what is the difference between the Number of enrolments of both sexes in Secondary and Number of enrolments of both sexes in Secondary vocational?
Keep it short and to the point. 9.85e+05. In the year 1988, what is the difference between the Number of enrolments of both sexes in Secondary general and Number of enrolments of both sexes in Secondary vocational?
Offer a very short reply. 8.07e+05. In the year 1989, what is the difference between the Number of enrolments of both sexes of Primary and Number of enrolments of both sexes of Secondary?
Your answer should be very brief. 1.86e+06. In the year 1989, what is the difference between the Number of enrolments of both sexes of Primary and Number of enrolments of both sexes of Secondary general?
Make the answer very short. 2.04e+06. In the year 1989, what is the difference between the Number of enrolments of both sexes of Primary and Number of enrolments of both sexes of Secondary vocational?
Give a very brief answer. 2.84e+06. In the year 1989, what is the difference between the Number of enrolments of both sexes in Secondary and Number of enrolments of both sexes in Secondary general?
Offer a terse response. 1.85e+05. In the year 1989, what is the difference between the Number of enrolments of both sexes of Secondary and Number of enrolments of both sexes of Secondary vocational?
Provide a short and direct response. 9.81e+05. In the year 1989, what is the difference between the Number of enrolments of both sexes of Secondary general and Number of enrolments of both sexes of Secondary vocational?
Provide a succinct answer. 7.96e+05. What is the ratio of the Number of enrolments of both sexes in Primary in 1983 to that in 1984?
Your answer should be compact. 0.97. What is the ratio of the Number of enrolments of both sexes of Secondary in 1983 to that in 1984?
Make the answer very short. 1. What is the ratio of the Number of enrolments of both sexes of Secondary general in 1983 to that in 1984?
Make the answer very short. 1.01. What is the ratio of the Number of enrolments of both sexes in Secondary vocational in 1983 to that in 1984?
Your response must be concise. 0.86. What is the ratio of the Number of enrolments of both sexes of Primary in 1983 to that in 1985?
Keep it short and to the point. 0.95. What is the ratio of the Number of enrolments of both sexes in Secondary in 1983 to that in 1985?
Make the answer very short. 0.94. What is the ratio of the Number of enrolments of both sexes of Secondary general in 1983 to that in 1985?
Keep it short and to the point. 0.98. What is the ratio of the Number of enrolments of both sexes in Secondary vocational in 1983 to that in 1985?
Make the answer very short. 0.68. What is the ratio of the Number of enrolments of both sexes in Primary in 1983 to that in 1986?
Your answer should be very brief. 0.93. What is the ratio of the Number of enrolments of both sexes of Secondary in 1983 to that in 1986?
Your response must be concise. 0.89. What is the ratio of the Number of enrolments of both sexes of Secondary general in 1983 to that in 1986?
Offer a terse response. 0.94. What is the ratio of the Number of enrolments of both sexes in Secondary vocational in 1983 to that in 1986?
Offer a terse response. 0.6. What is the ratio of the Number of enrolments of both sexes in Primary in 1983 to that in 1987?
Your response must be concise. 0.9. What is the ratio of the Number of enrolments of both sexes of Secondary in 1983 to that in 1987?
Your answer should be compact. 0.9. What is the ratio of the Number of enrolments of both sexes in Secondary general in 1983 to that in 1987?
Keep it short and to the point. 0.96. What is the ratio of the Number of enrolments of both sexes of Secondary vocational in 1983 to that in 1987?
Ensure brevity in your answer.  0.55. What is the ratio of the Number of enrolments of both sexes of Primary in 1983 to that in 1988?
Make the answer very short. 0.87. What is the ratio of the Number of enrolments of both sexes of Secondary in 1983 to that in 1988?
Offer a very short reply. 0.92. What is the ratio of the Number of enrolments of both sexes in Secondary vocational in 1983 to that in 1988?
Your answer should be compact. 0.51. What is the ratio of the Number of enrolments of both sexes in Primary in 1983 to that in 1989?
Make the answer very short. 0.87. What is the ratio of the Number of enrolments of both sexes in Secondary in 1983 to that in 1989?
Ensure brevity in your answer.  0.91. What is the ratio of the Number of enrolments of both sexes in Secondary vocational in 1983 to that in 1989?
Your answer should be very brief. 0.49. What is the ratio of the Number of enrolments of both sexes of Primary in 1984 to that in 1985?
Ensure brevity in your answer.  0.98. What is the ratio of the Number of enrolments of both sexes of Secondary in 1984 to that in 1985?
Your answer should be very brief. 0.94. What is the ratio of the Number of enrolments of both sexes in Secondary general in 1984 to that in 1985?
Offer a very short reply. 0.96. What is the ratio of the Number of enrolments of both sexes of Secondary vocational in 1984 to that in 1985?
Offer a very short reply. 0.79. What is the ratio of the Number of enrolments of both sexes in Primary in 1984 to that in 1986?
Your answer should be very brief. 0.96. What is the ratio of the Number of enrolments of both sexes in Secondary in 1984 to that in 1986?
Your answer should be compact. 0.9. What is the ratio of the Number of enrolments of both sexes in Secondary general in 1984 to that in 1986?
Your answer should be compact. 0.93. What is the ratio of the Number of enrolments of both sexes in Secondary vocational in 1984 to that in 1986?
Give a very brief answer. 0.7. What is the ratio of the Number of enrolments of both sexes in Primary in 1984 to that in 1987?
Ensure brevity in your answer.  0.92. What is the ratio of the Number of enrolments of both sexes in Secondary in 1984 to that in 1987?
Provide a succinct answer. 0.91. What is the ratio of the Number of enrolments of both sexes in Secondary general in 1984 to that in 1987?
Give a very brief answer. 0.95. What is the ratio of the Number of enrolments of both sexes in Secondary vocational in 1984 to that in 1987?
Provide a succinct answer. 0.64. What is the ratio of the Number of enrolments of both sexes in Primary in 1984 to that in 1988?
Your response must be concise. 0.9. What is the ratio of the Number of enrolments of both sexes in Secondary in 1984 to that in 1988?
Make the answer very short. 0.92. What is the ratio of the Number of enrolments of both sexes of Secondary general in 1984 to that in 1988?
Your response must be concise. 0.98. What is the ratio of the Number of enrolments of both sexes in Secondary vocational in 1984 to that in 1988?
Offer a terse response. 0.59. What is the ratio of the Number of enrolments of both sexes in Primary in 1984 to that in 1989?
Give a very brief answer. 0.89. What is the ratio of the Number of enrolments of both sexes of Secondary in 1984 to that in 1989?
Provide a succinct answer. 0.92. What is the ratio of the Number of enrolments of both sexes of Secondary general in 1984 to that in 1989?
Ensure brevity in your answer.  0.98. What is the ratio of the Number of enrolments of both sexes in Secondary vocational in 1984 to that in 1989?
Ensure brevity in your answer.  0.57. What is the ratio of the Number of enrolments of both sexes of Primary in 1985 to that in 1986?
Offer a very short reply. 0.98. What is the ratio of the Number of enrolments of both sexes in Secondary in 1985 to that in 1986?
Provide a short and direct response. 0.95. What is the ratio of the Number of enrolments of both sexes in Secondary vocational in 1985 to that in 1986?
Your answer should be very brief. 0.88. What is the ratio of the Number of enrolments of both sexes in Primary in 1985 to that in 1987?
Keep it short and to the point. 0.94. What is the ratio of the Number of enrolments of both sexes in Secondary in 1985 to that in 1987?
Keep it short and to the point. 0.96. What is the ratio of the Number of enrolments of both sexes of Secondary vocational in 1985 to that in 1987?
Offer a very short reply. 0.81. What is the ratio of the Number of enrolments of both sexes of Primary in 1985 to that in 1988?
Keep it short and to the point. 0.92. What is the ratio of the Number of enrolments of both sexes in Secondary in 1985 to that in 1988?
Ensure brevity in your answer.  0.97. What is the ratio of the Number of enrolments of both sexes in Secondary general in 1985 to that in 1988?
Give a very brief answer. 1.01. What is the ratio of the Number of enrolments of both sexes of Secondary vocational in 1985 to that in 1988?
Offer a terse response. 0.75. What is the ratio of the Number of enrolments of both sexes of Primary in 1985 to that in 1989?
Your answer should be very brief. 0.91. What is the ratio of the Number of enrolments of both sexes in Secondary in 1985 to that in 1989?
Offer a terse response. 0.97. What is the ratio of the Number of enrolments of both sexes in Secondary general in 1985 to that in 1989?
Ensure brevity in your answer.  1.02. What is the ratio of the Number of enrolments of both sexes in Secondary vocational in 1985 to that in 1989?
Offer a very short reply. 0.72. What is the ratio of the Number of enrolments of both sexes of Primary in 1986 to that in 1987?
Give a very brief answer. 0.96. What is the ratio of the Number of enrolments of both sexes of Secondary in 1986 to that in 1987?
Your answer should be compact. 1.01. What is the ratio of the Number of enrolments of both sexes in Secondary general in 1986 to that in 1987?
Ensure brevity in your answer.  1.03. What is the ratio of the Number of enrolments of both sexes of Secondary vocational in 1986 to that in 1987?
Your response must be concise. 0.92. What is the ratio of the Number of enrolments of both sexes in Primary in 1986 to that in 1988?
Your answer should be compact. 0.94. What is the ratio of the Number of enrolments of both sexes in Secondary in 1986 to that in 1988?
Provide a short and direct response. 1.02. What is the ratio of the Number of enrolments of both sexes in Secondary general in 1986 to that in 1988?
Offer a terse response. 1.05. What is the ratio of the Number of enrolments of both sexes of Secondary vocational in 1986 to that in 1988?
Provide a short and direct response. 0.85. What is the ratio of the Number of enrolments of both sexes in Primary in 1986 to that in 1989?
Offer a very short reply. 0.93. What is the ratio of the Number of enrolments of both sexes of Secondary in 1986 to that in 1989?
Ensure brevity in your answer.  1.02. What is the ratio of the Number of enrolments of both sexes of Secondary general in 1986 to that in 1989?
Your answer should be compact. 1.06. What is the ratio of the Number of enrolments of both sexes in Secondary vocational in 1986 to that in 1989?
Keep it short and to the point. 0.82. What is the ratio of the Number of enrolments of both sexes of Primary in 1987 to that in 1988?
Provide a succinct answer. 0.97. What is the ratio of the Number of enrolments of both sexes in Secondary in 1987 to that in 1988?
Offer a very short reply. 1.01. What is the ratio of the Number of enrolments of both sexes in Secondary general in 1987 to that in 1988?
Offer a terse response. 1.03. What is the ratio of the Number of enrolments of both sexes in Secondary vocational in 1987 to that in 1988?
Your answer should be compact. 0.93. What is the ratio of the Number of enrolments of both sexes in Primary in 1987 to that in 1989?
Make the answer very short. 0.97. What is the ratio of the Number of enrolments of both sexes of Secondary in 1987 to that in 1989?
Give a very brief answer. 1.01. What is the ratio of the Number of enrolments of both sexes of Secondary general in 1987 to that in 1989?
Offer a very short reply. 1.03. What is the ratio of the Number of enrolments of both sexes in Secondary vocational in 1987 to that in 1989?
Provide a succinct answer. 0.9. What is the ratio of the Number of enrolments of both sexes in Secondary general in 1988 to that in 1989?
Offer a terse response. 1. What is the ratio of the Number of enrolments of both sexes of Secondary vocational in 1988 to that in 1989?
Offer a terse response. 0.96. What is the difference between the highest and the second highest Number of enrolments of both sexes of Primary?
Your answer should be compact. 2.62e+04. What is the difference between the highest and the second highest Number of enrolments of both sexes in Secondary?
Your response must be concise. 1.21e+04. What is the difference between the highest and the second highest Number of enrolments of both sexes of Secondary general?
Make the answer very short. 2.62e+04. What is the difference between the highest and the second highest Number of enrolments of both sexes of Secondary vocational?
Provide a short and direct response. 6879. What is the difference between the highest and the lowest Number of enrolments of both sexes of Primary?
Keep it short and to the point. 4.02e+05. What is the difference between the highest and the lowest Number of enrolments of both sexes in Secondary?
Offer a terse response. 1.25e+05. What is the difference between the highest and the lowest Number of enrolments of both sexes in Secondary general?
Make the answer very short. 7.66e+04. What is the difference between the highest and the lowest Number of enrolments of both sexes of Secondary vocational?
Give a very brief answer. 9.41e+04. 